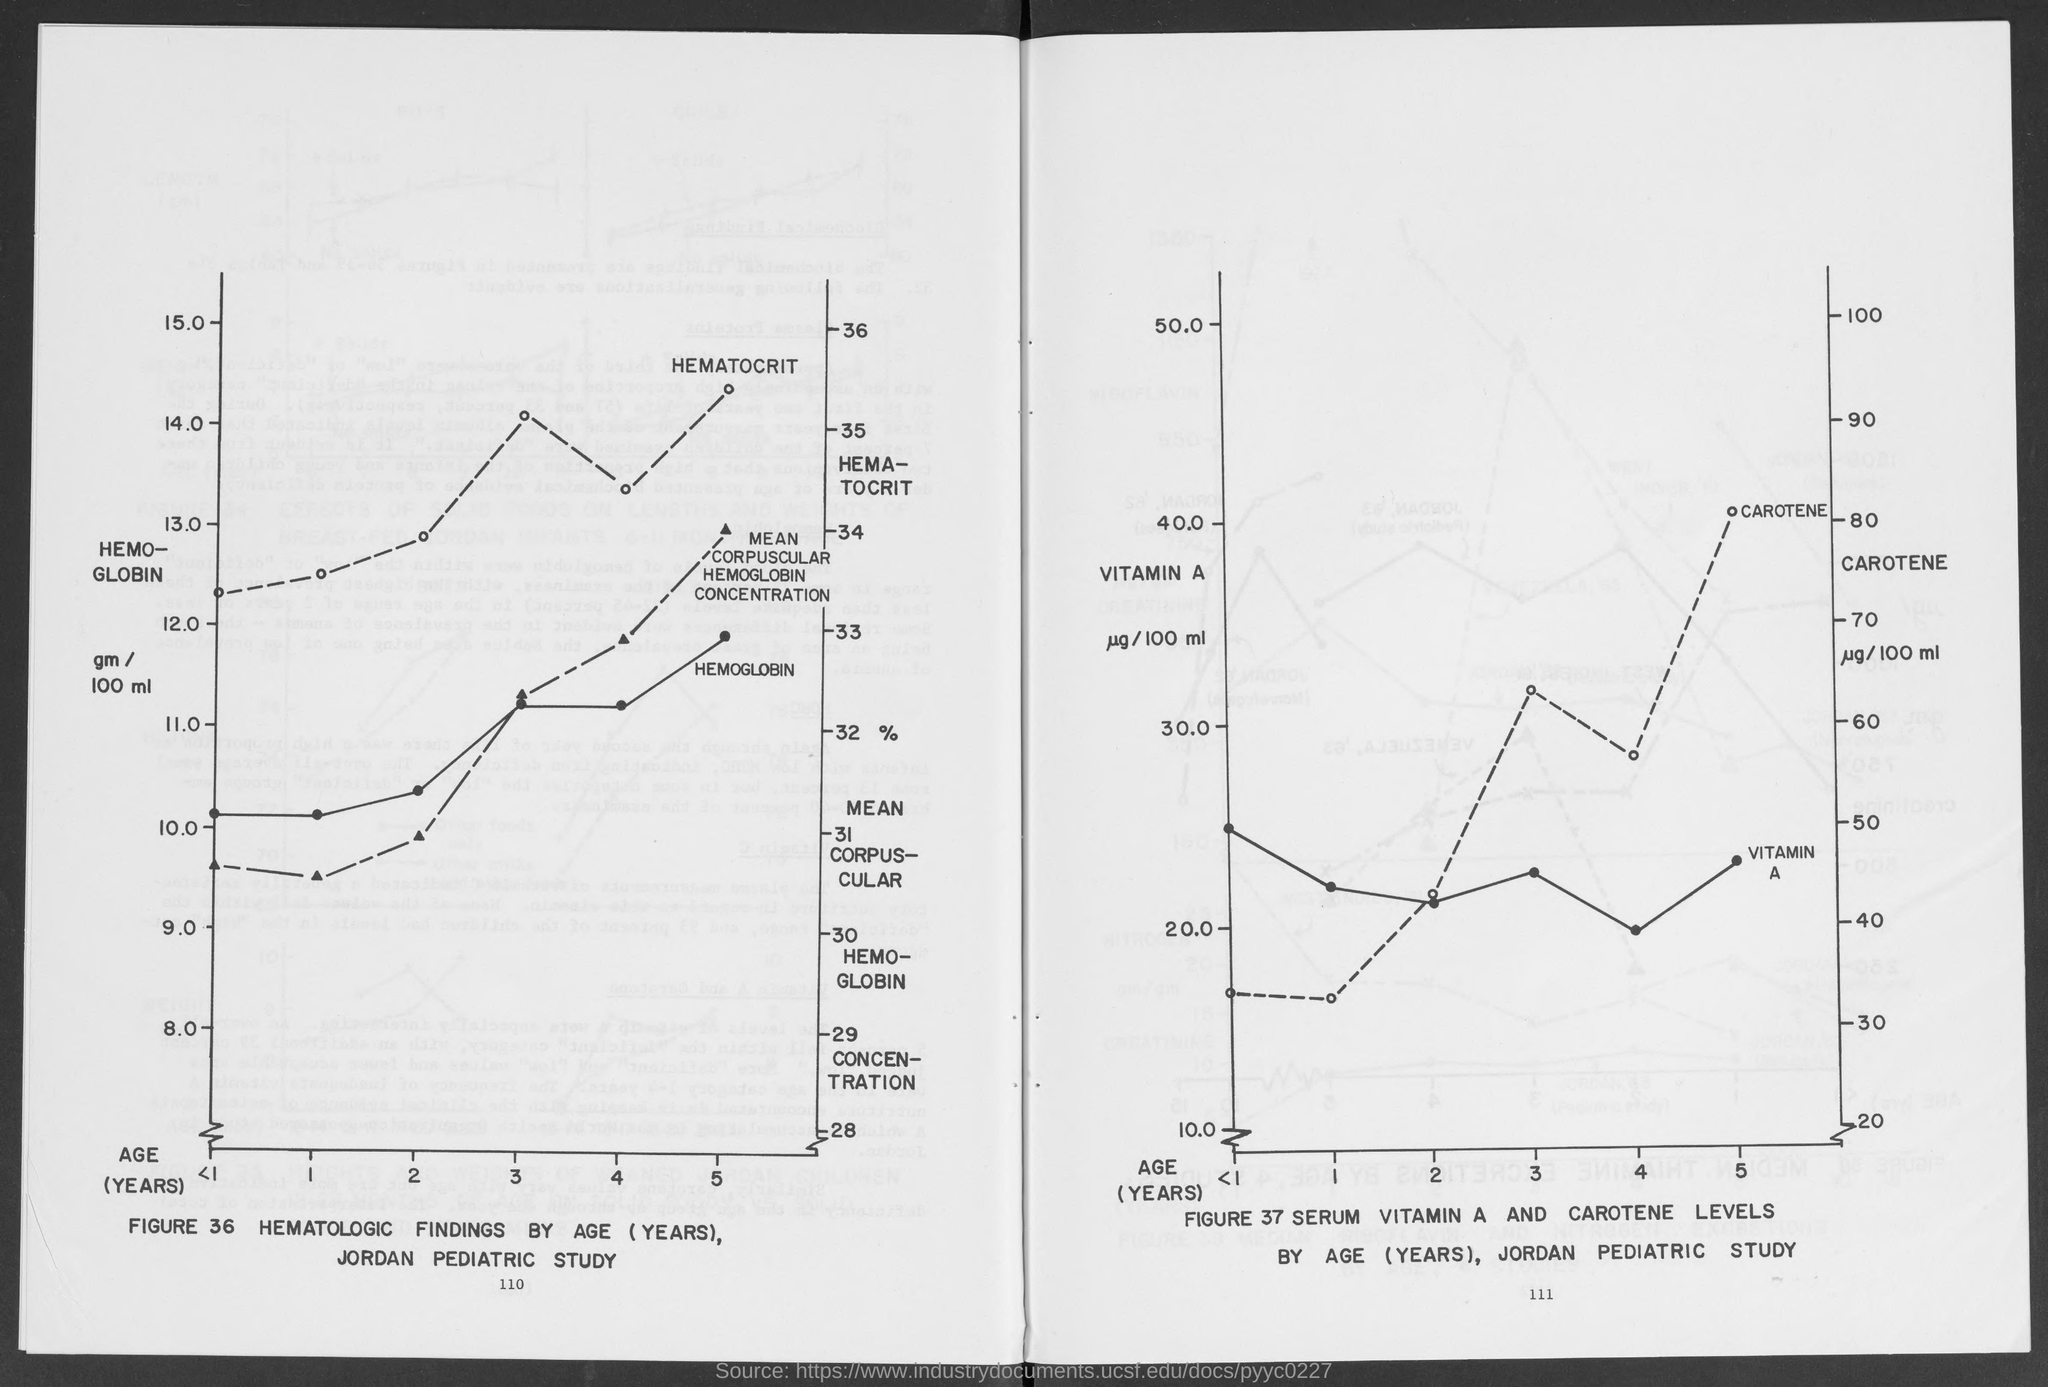What is the maximum value of Vitamin A, shown on the Y axis in figure 37?
Provide a succinct answer. 50.0. What is the max value of hemoglobin, shown in Figure 36?
Provide a short and direct response. 15.0. Whose study of  "HEMATOLOGIC FINDINGS BY AGE (YEARS)"  is shown in"FIGURE 36"?
Ensure brevity in your answer.  JORDAN PEDIATRIC STUDY. Whose study of "SERUM VITAMIN A AND CAROTENE LEVELS  BY AGE (YEARS)" is shown in"FIGURE 37"?
Offer a very short reply. JORDAN PEDIATRIC STUDY. What is the maximum AGE (YEARS)  taken for study in "FIGURE 36"?
Keep it short and to the point. 5. What is the maximum AGE (YEARS) taken for study in "FIGURE 37"?
Give a very brief answer. 5. What is the minimum value of "HEMOGLOBIN gm / 100 ml"  shown in "FIGURE 36"?
Keep it short and to the point. 8. What is the maximum value of "HEMOGLOBIN gm / 100 ml" shown in "FIGURE 36"?
Give a very brief answer. 15.0. "HEMATOLOGIC FINDINGS" based on what is shown in "FIGURE 36"?
Make the answer very short. AGE (YEARS). 